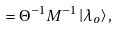Convert formula to latex. <formula><loc_0><loc_0><loc_500><loc_500>= \Theta ^ { - 1 } M ^ { - 1 } \left | \lambda _ { o } \right \rangle ,</formula> 